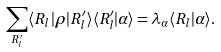<formula> <loc_0><loc_0><loc_500><loc_500>\sum _ { R ^ { \prime } _ { l } } \langle R _ { l } | \rho | R ^ { \prime } _ { l } \rangle \langle R ^ { \prime } _ { l } | \alpha \rangle = \lambda _ { \alpha } \langle R _ { l } | \alpha \rangle .</formula> 